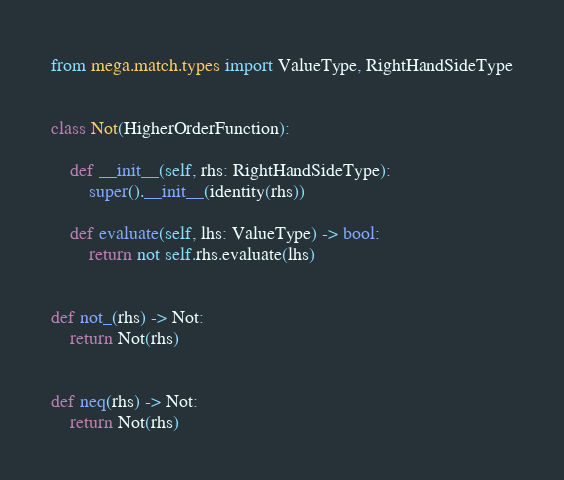Convert code to text. <code><loc_0><loc_0><loc_500><loc_500><_Python_>from mega.match.types import ValueType, RightHandSideType


class Not(HigherOrderFunction):

    def __init__(self, rhs: RightHandSideType):
        super().__init__(identity(rhs))

    def evaluate(self, lhs: ValueType) -> bool:
        return not self.rhs.evaluate(lhs)


def not_(rhs) -> Not:
    return Not(rhs)


def neq(rhs) -> Not:
    return Not(rhs)
</code> 